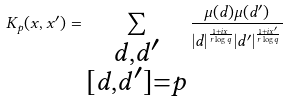<formula> <loc_0><loc_0><loc_500><loc_500>K _ { p } ( x , x ^ { \prime } ) = \sum _ { \substack { d , d ^ { \prime } \\ [ d , d ^ { \prime } ] = p } } \frac { \mu ( d ) \mu ( d ^ { \prime } ) } { | d | ^ { \frac { 1 + i x } { r \log q } } | d ^ { \prime } | ^ { \frac { 1 + i x ^ { \prime } } { r \log q } } }</formula> 